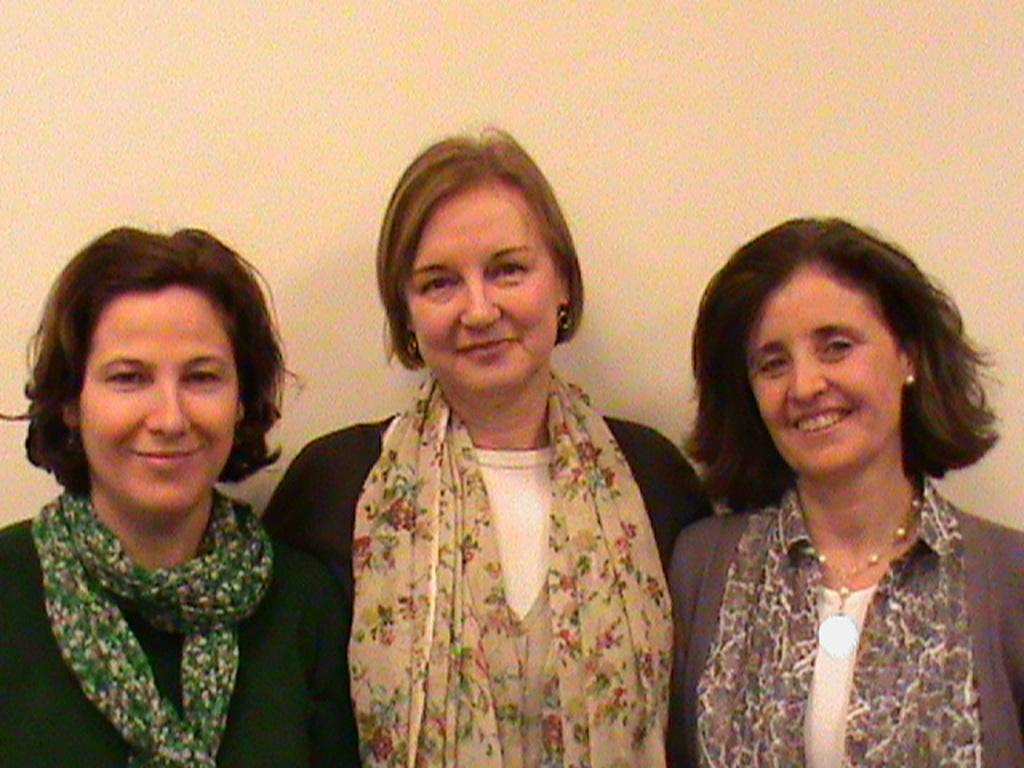How many women are present in the image? There are three women in the image. What are the women doing in the image? The women are standing. What can be seen in the background of the image? There is a wall visible in the image. What type of scent can be smelled coming from the women in the image? There is no indication of a scent in the image, as smells cannot be captured in a photograph. What type of pet is visible in the image? There is no pet present in the image; it features three women standing. What type of musical instrument is being played by one of the women in the image? There is no musical instrument, such as a guitar, present in the image. 